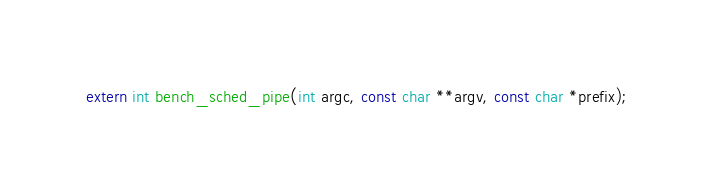<code> <loc_0><loc_0><loc_500><loc_500><_C_>extern int bench_sched_pipe(int argc, const char **argv, const char *prefix);</code> 